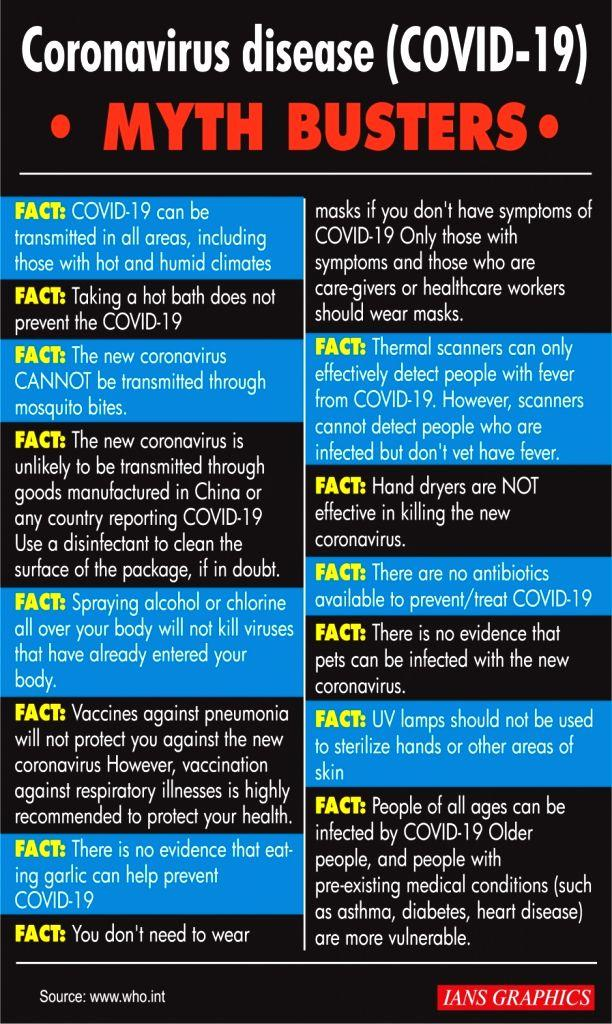Specify some key components in this picture. There are 14 facts about coronavirus disease in this infographic. There are 3 medical conditions in this infographic. 